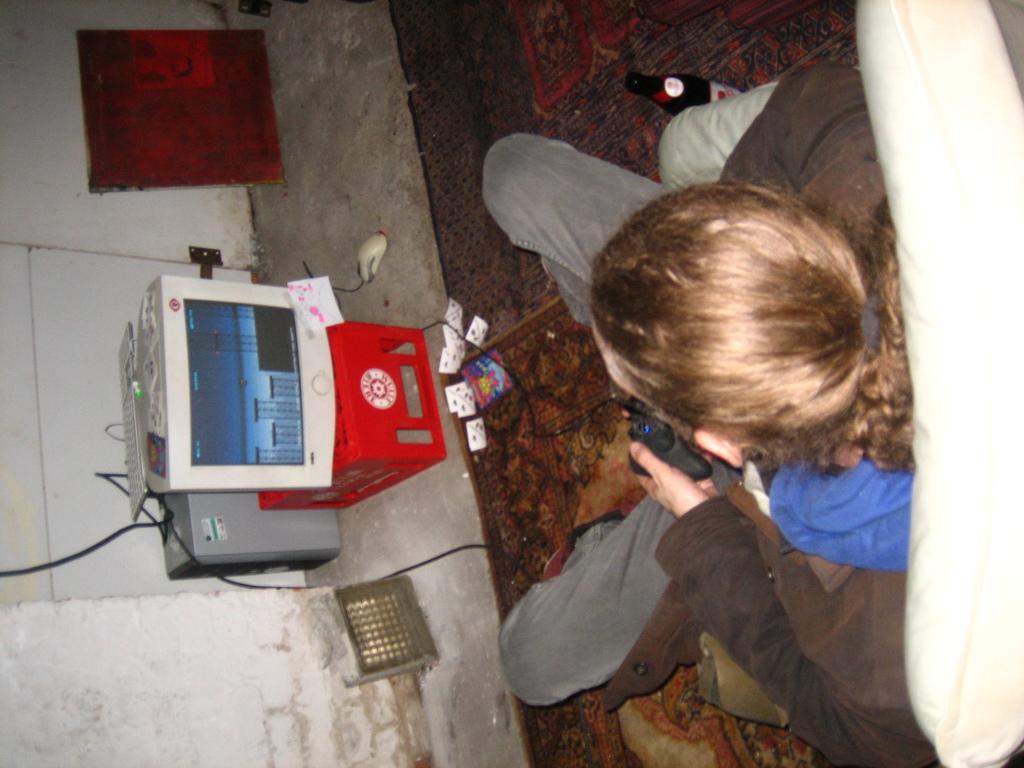Please provide a concise description of this image. In this image there is a person. There is a bottle beside him. There is a monitor. There is a CPU. There is a mouse. There is a red color object under the monitor. There is a red color cardboard. There is a wall. 